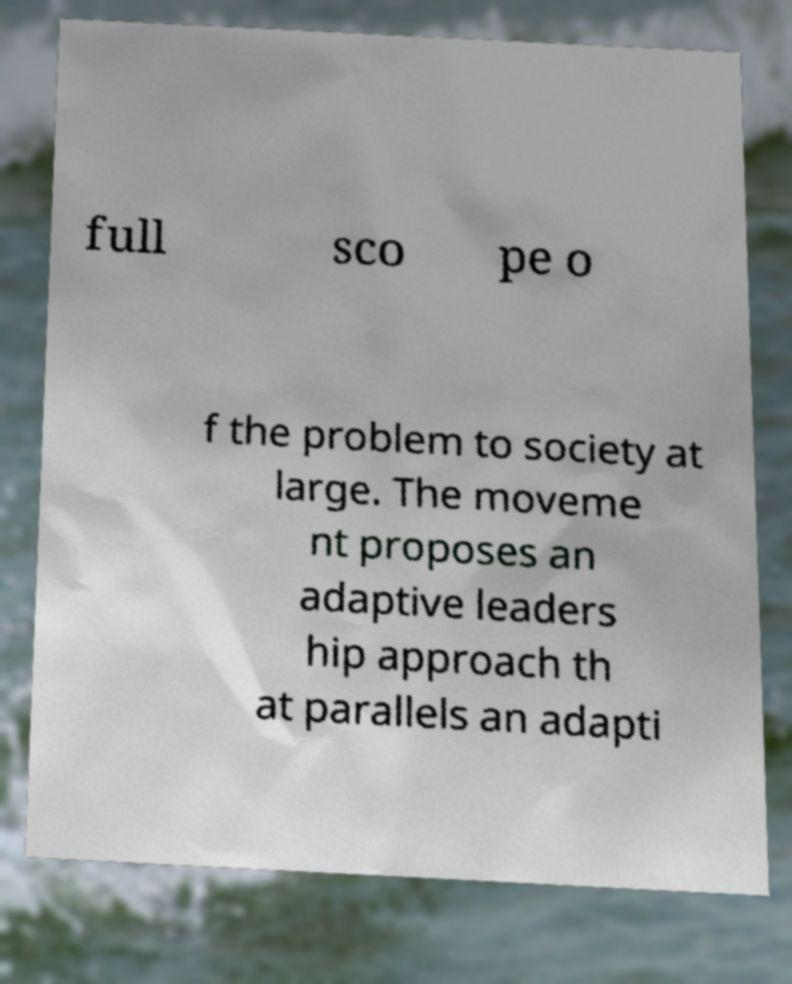I need the written content from this picture converted into text. Can you do that? full sco pe o f the problem to society at large. The moveme nt proposes an adaptive leaders hip approach th at parallels an adapti 